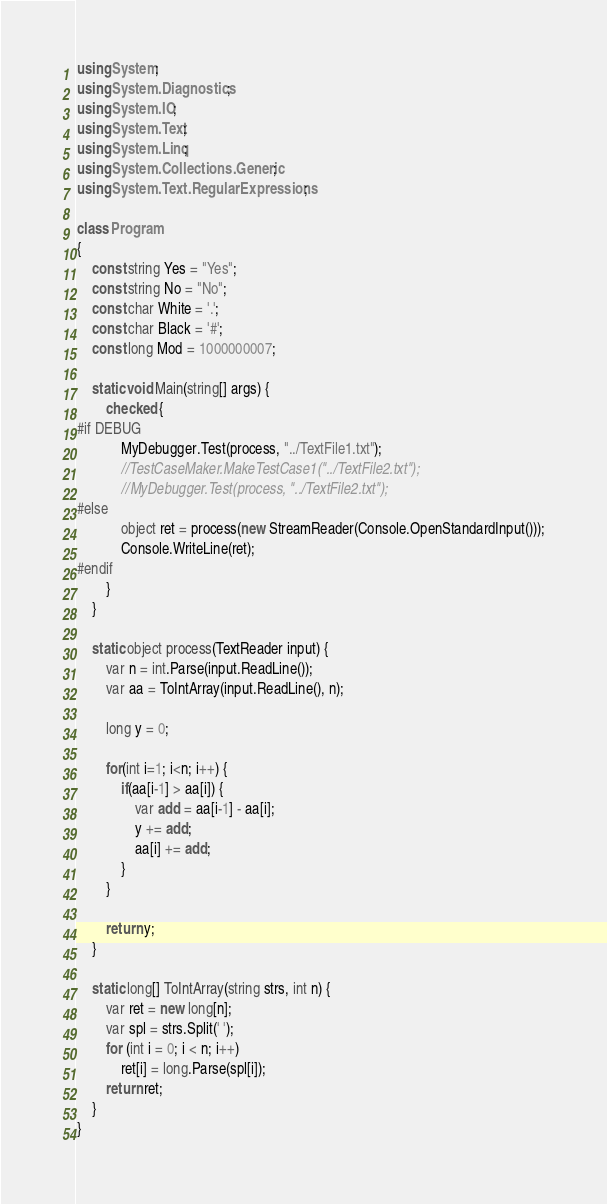Convert code to text. <code><loc_0><loc_0><loc_500><loc_500><_C#_>using System;
using System.Diagnostics;
using System.IO;
using System.Text;
using System.Linq;
using System.Collections.Generic;
using System.Text.RegularExpressions;

class Program
{
    const string Yes = "Yes";
    const string No = "No";
    const char White = '.';
    const char Black = '#';
    const long Mod = 1000000007;

    static void Main(string[] args) {
        checked {
#if DEBUG
            MyDebugger.Test(process, "../TextFile1.txt");
            //TestCaseMaker.MakeTestCase1("../TextFile2.txt");
            //MyDebugger.Test(process, "../TextFile2.txt");
#else
            object ret = process(new StreamReader(Console.OpenStandardInput()));
            Console.WriteLine(ret);
#endif
        }
    }

    static object process(TextReader input) {
        var n = int.Parse(input.ReadLine());
        var aa = ToIntArray(input.ReadLine(), n);

        long y = 0;

        for(int i=1; i<n; i++) {
            if(aa[i-1] > aa[i]) {
                var add = aa[i-1] - aa[i];
                y += add;
                aa[i] += add;
            }
        }

        return y;
    }

    static long[] ToIntArray(string strs, int n) {
        var ret = new long[n];
        var spl = strs.Split(' ');
        for (int i = 0; i < n; i++)
            ret[i] = long.Parse(spl[i]);
        return ret;
    }
}
</code> 